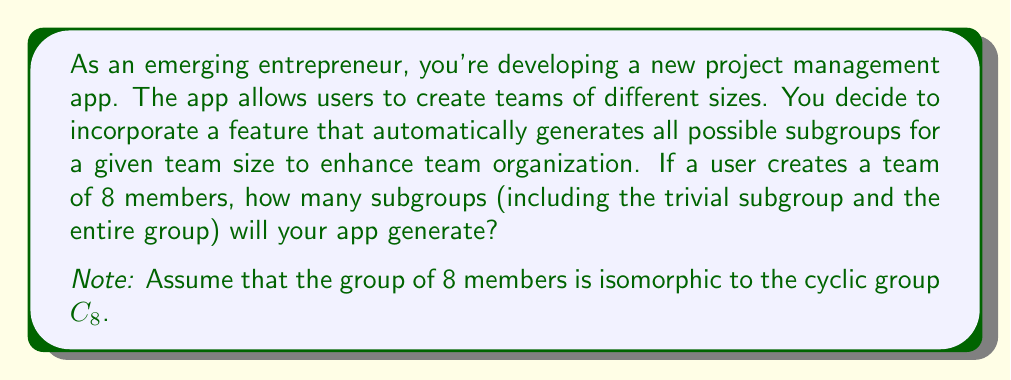What is the answer to this math problem? To solve this problem, we need to follow these steps:

1) First, recall that for a cyclic group of order $n$, the number of subgroups is equal to the number of divisors of $n$.

2) In this case, we have a group of order 8, so we need to find the divisors of 8.

3) The divisors of 8 are: 1, 2, 4, and 8.

4) To understand why these are the only subgroups, let's consider the structure of $C_8$:

   $C_8 = \{e, a, a^2, a^3, a^4, a^5, a^6, a^7\}$ where $a^8 = e$

5) The subgroups correspond to:
   - $\{e\}$ (order 1)
   - $\{e, a^4\}$ (order 2)
   - $\{e, a^2, a^4, a^6\}$ (order 4)
   - $\{e, a, a^2, a^3, a^4, a^5, a^6, a^7\}$ (order 8)

6) Each of these subgroups is generated by an element of $C_8$:
   - $\langle e \rangle = \{e\}$
   - $\langle a^4 \rangle = \{e, a^4\}$
   - $\langle a^2 \rangle = \{e, a^2, a^4, a^6\}$
   - $\langle a \rangle = C_8$

Therefore, the number of subgroups is equal to the number of divisors of 8, which is 4.

This approach of using the number of divisors works specifically for cyclic groups. For non-cyclic groups, the process of finding the number of subgroups can be more complex.
Answer: The app will generate 4 subgroups. 